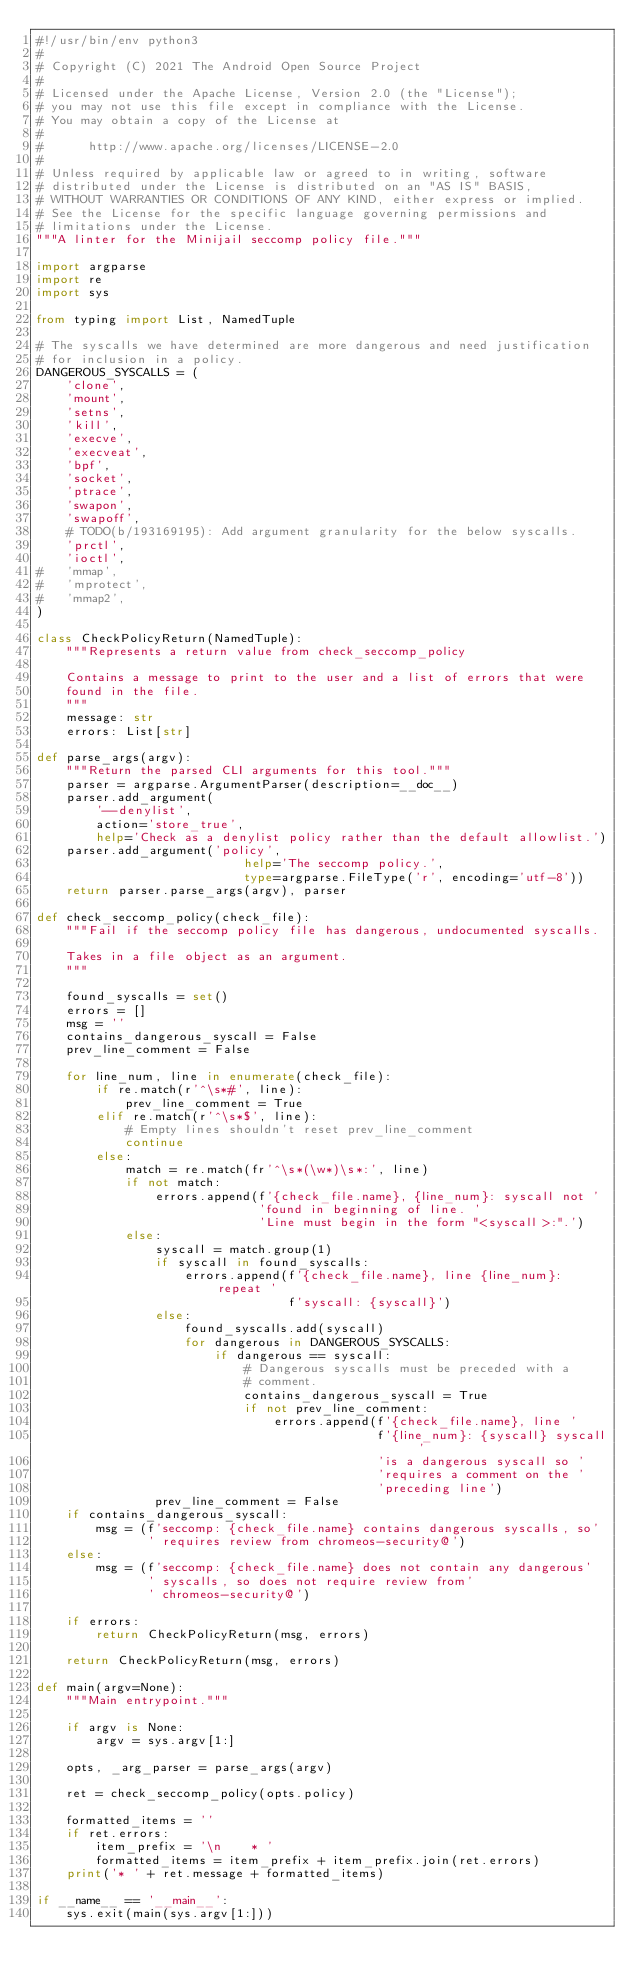<code> <loc_0><loc_0><loc_500><loc_500><_Python_>#!/usr/bin/env python3
#
# Copyright (C) 2021 The Android Open Source Project
#
# Licensed under the Apache License, Version 2.0 (the "License");
# you may not use this file except in compliance with the License.
# You may obtain a copy of the License at
#
#      http://www.apache.org/licenses/LICENSE-2.0
#
# Unless required by applicable law or agreed to in writing, software
# distributed under the License is distributed on an "AS IS" BASIS,
# WITHOUT WARRANTIES OR CONDITIONS OF ANY KIND, either express or implied.
# See the License for the specific language governing permissions and
# limitations under the License.
"""A linter for the Minijail seccomp policy file."""

import argparse
import re
import sys

from typing import List, NamedTuple

# The syscalls we have determined are more dangerous and need justification
# for inclusion in a policy.
DANGEROUS_SYSCALLS = (
    'clone',
    'mount',
    'setns',
    'kill',
    'execve',
    'execveat',
    'bpf',
    'socket',
    'ptrace',
    'swapon',
    'swapoff',
    # TODO(b/193169195): Add argument granularity for the below syscalls.
    'prctl',
    'ioctl',
#   'mmap',
#   'mprotect',
#   'mmap2',
)

class CheckPolicyReturn(NamedTuple):
    """Represents a return value from check_seccomp_policy

    Contains a message to print to the user and a list of errors that were
    found in the file.
    """
    message: str
    errors: List[str]

def parse_args(argv):
    """Return the parsed CLI arguments for this tool."""
    parser = argparse.ArgumentParser(description=__doc__)
    parser.add_argument(
        '--denylist',
        action='store_true',
        help='Check as a denylist policy rather than the default allowlist.')
    parser.add_argument('policy',
                            help='The seccomp policy.',
                            type=argparse.FileType('r', encoding='utf-8'))
    return parser.parse_args(argv), parser

def check_seccomp_policy(check_file):
    """Fail if the seccomp policy file has dangerous, undocumented syscalls.

    Takes in a file object as an argument.
    """

    found_syscalls = set()
    errors = []
    msg = ''
    contains_dangerous_syscall = False
    prev_line_comment = False

    for line_num, line in enumerate(check_file):
        if re.match(r'^\s*#', line):
            prev_line_comment = True
        elif re.match(r'^\s*$', line):
            # Empty lines shouldn't reset prev_line_comment
            continue
        else:
            match = re.match(fr'^\s*(\w*)\s*:', line)
            if not match:
                errors.append(f'{check_file.name}, {line_num}: syscall not '
                              'found in beginning of line. '
                              'Line must begin in the form "<syscall>:".')
            else:
                syscall = match.group(1)
                if syscall in found_syscalls:
                    errors.append(f'{check_file.name}, line {line_num}: repeat '
                                  f'syscall: {syscall}')
                else:
                    found_syscalls.add(syscall)
                    for dangerous in DANGEROUS_SYSCALLS:
                        if dangerous == syscall:
                            # Dangerous syscalls must be preceded with a
                            # comment.
                            contains_dangerous_syscall = True
                            if not prev_line_comment:
                                errors.append(f'{check_file.name}, line '
                                              f'{line_num}: {syscall} syscall '
                                              'is a dangerous syscall so '
                                              'requires a comment on the '
                                              'preceding line')
                prev_line_comment = False
    if contains_dangerous_syscall:
        msg = (f'seccomp: {check_file.name} contains dangerous syscalls, so'
               ' requires review from chromeos-security@')
    else:
        msg = (f'seccomp: {check_file.name} does not contain any dangerous'
               ' syscalls, so does not require review from'
               ' chromeos-security@')

    if errors:
        return CheckPolicyReturn(msg, errors)

    return CheckPolicyReturn(msg, errors)

def main(argv=None):
    """Main entrypoint."""

    if argv is None:
        argv = sys.argv[1:]

    opts, _arg_parser = parse_args(argv)

    ret = check_seccomp_policy(opts.policy)

    formatted_items = ''
    if ret.errors:
        item_prefix = '\n    * '
        formatted_items = item_prefix + item_prefix.join(ret.errors)
    print('* ' + ret.message + formatted_items)

if __name__ == '__main__':
    sys.exit(main(sys.argv[1:]))
</code> 